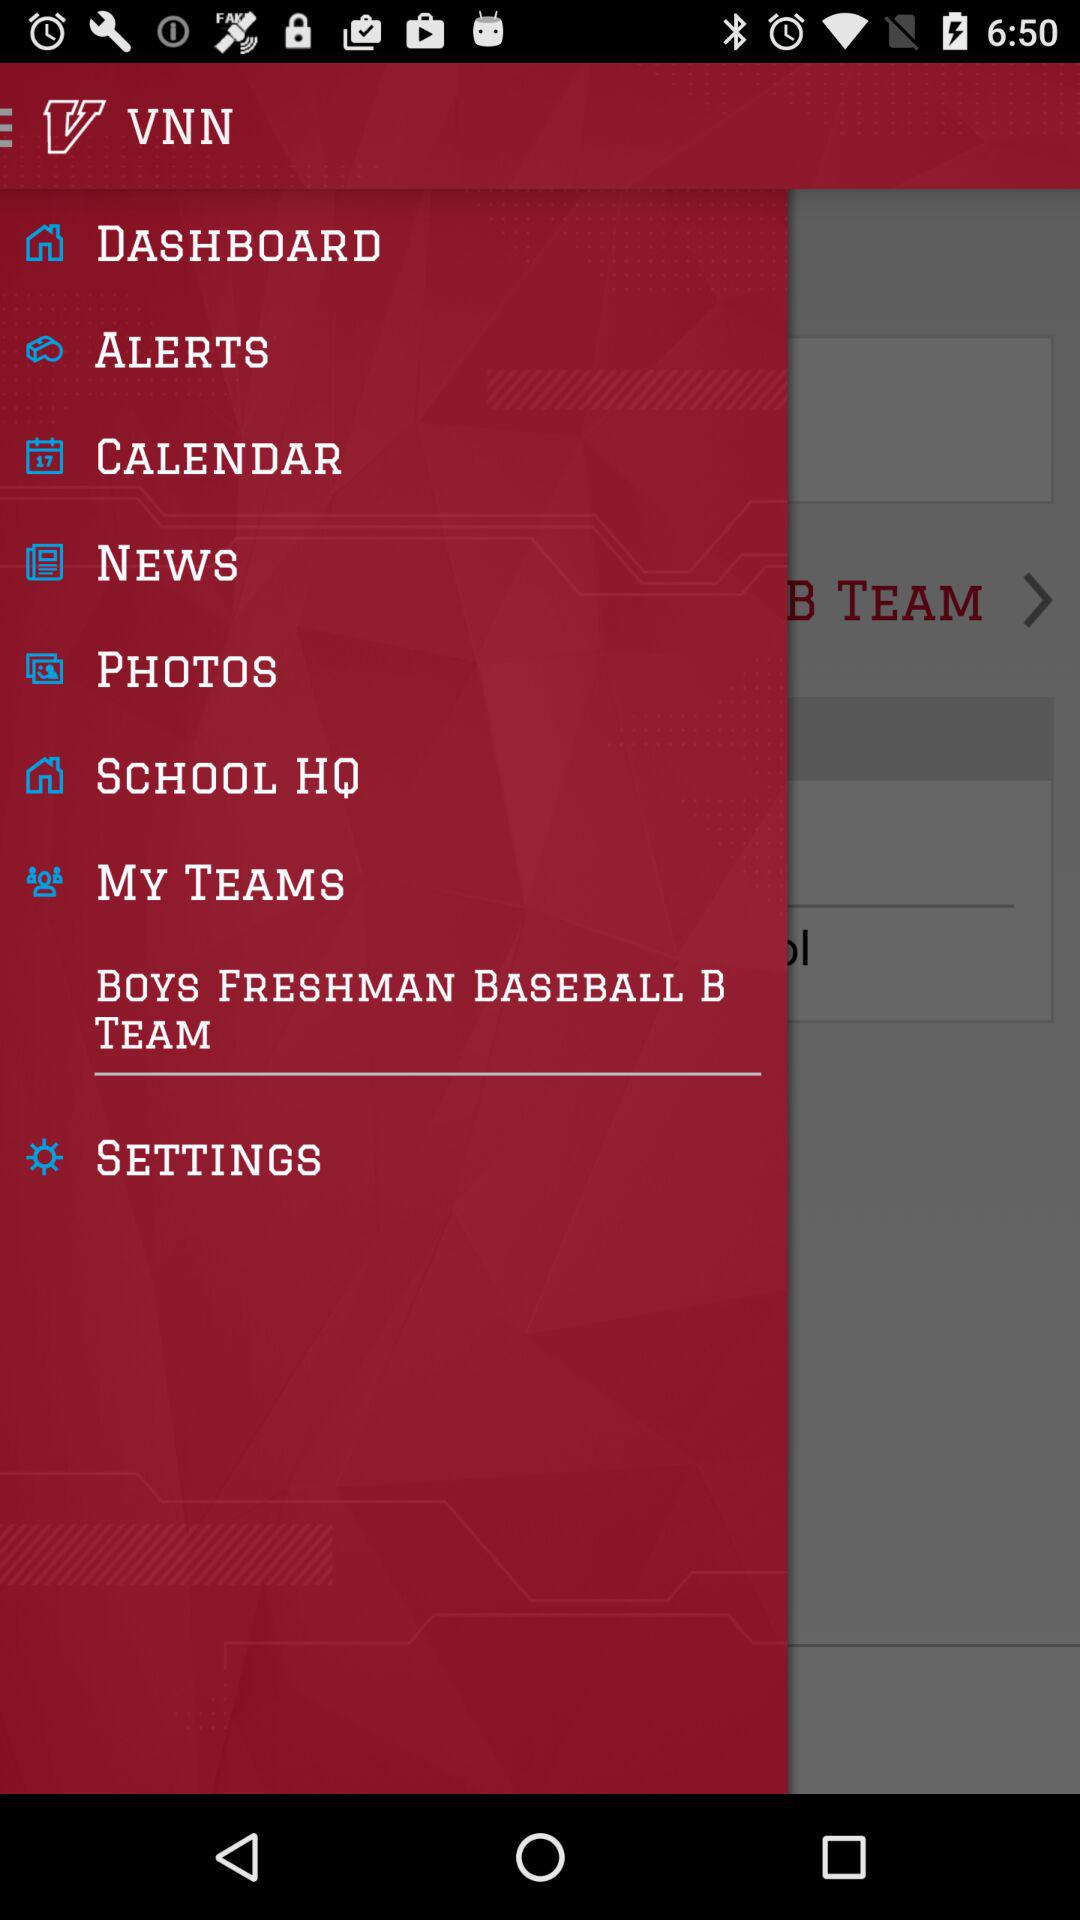What is the application name? The application name is "VNN". 